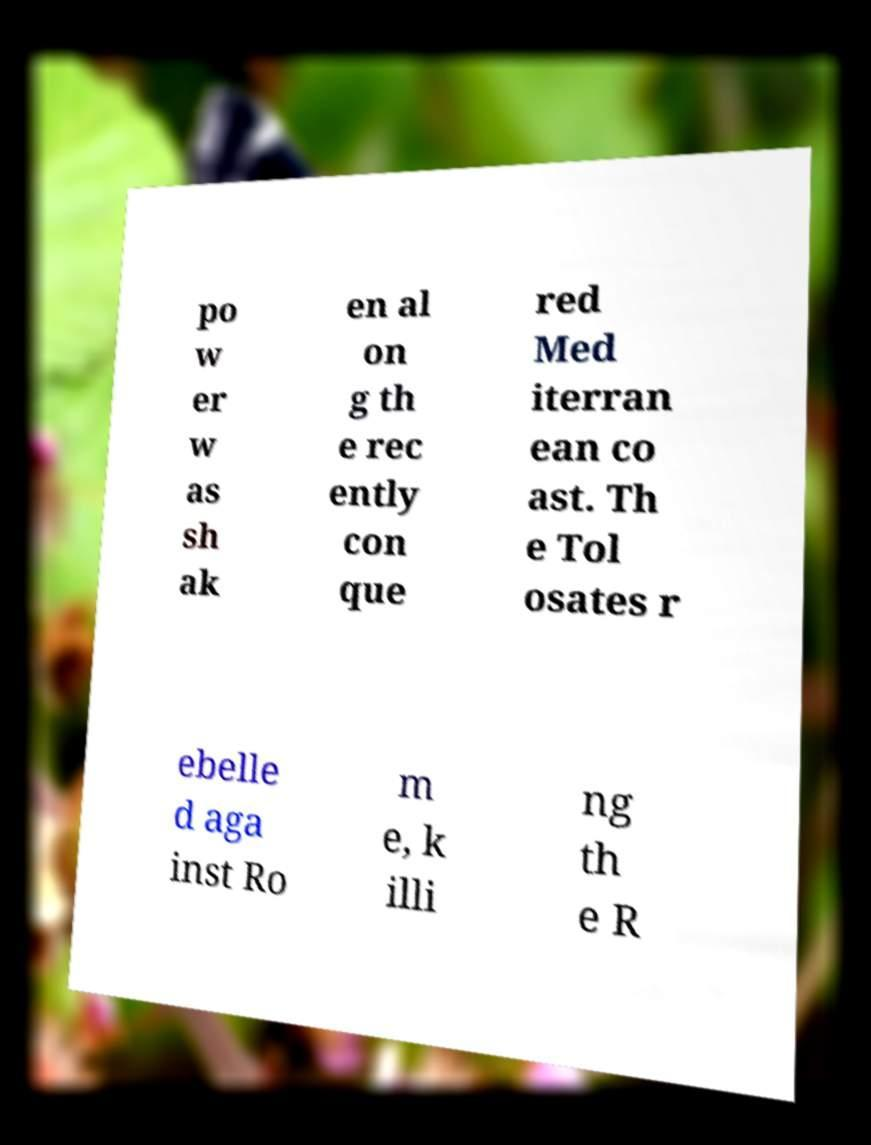What messages or text are displayed in this image? I need them in a readable, typed format. po w er w as sh ak en al on g th e rec ently con que red Med iterran ean co ast. Th e Tol osates r ebelle d aga inst Ro m e, k illi ng th e R 